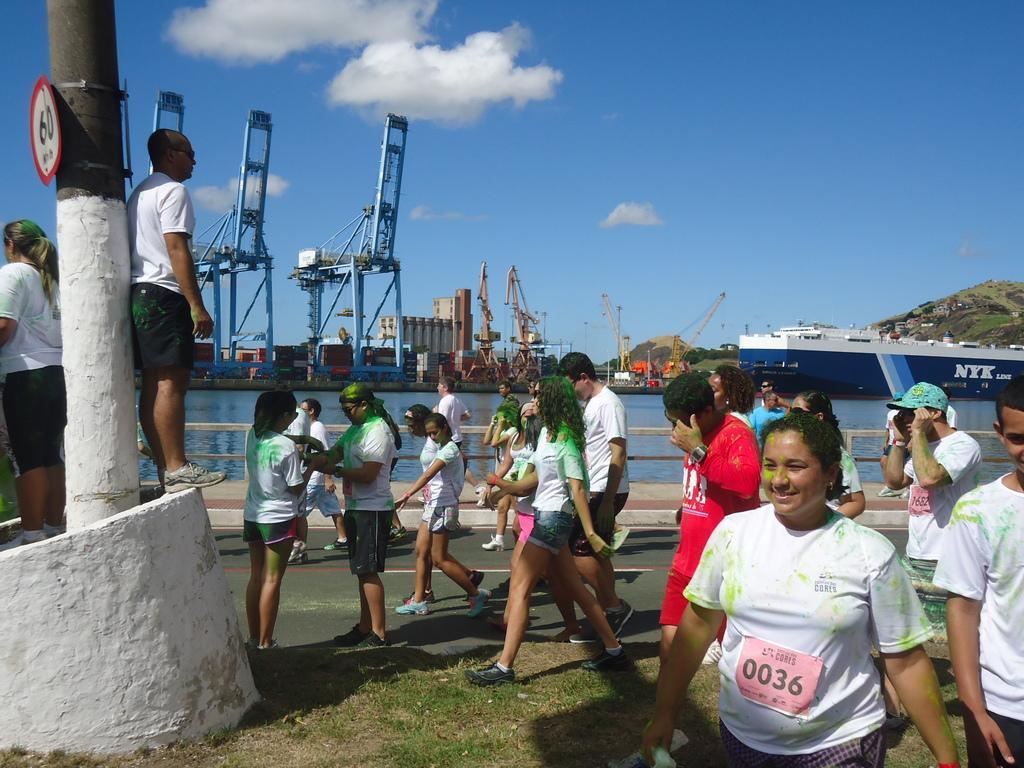How would you summarize this image in a sentence or two? There are few people walking and few people standing. This looks like a tree trunk. I can see a signboard, which is attached to the tree trunk. I think these are the tower cranes. Here is the water. This looks like a ship. On the right side of the image, I can see a hill. These are the clouds in the sky. 